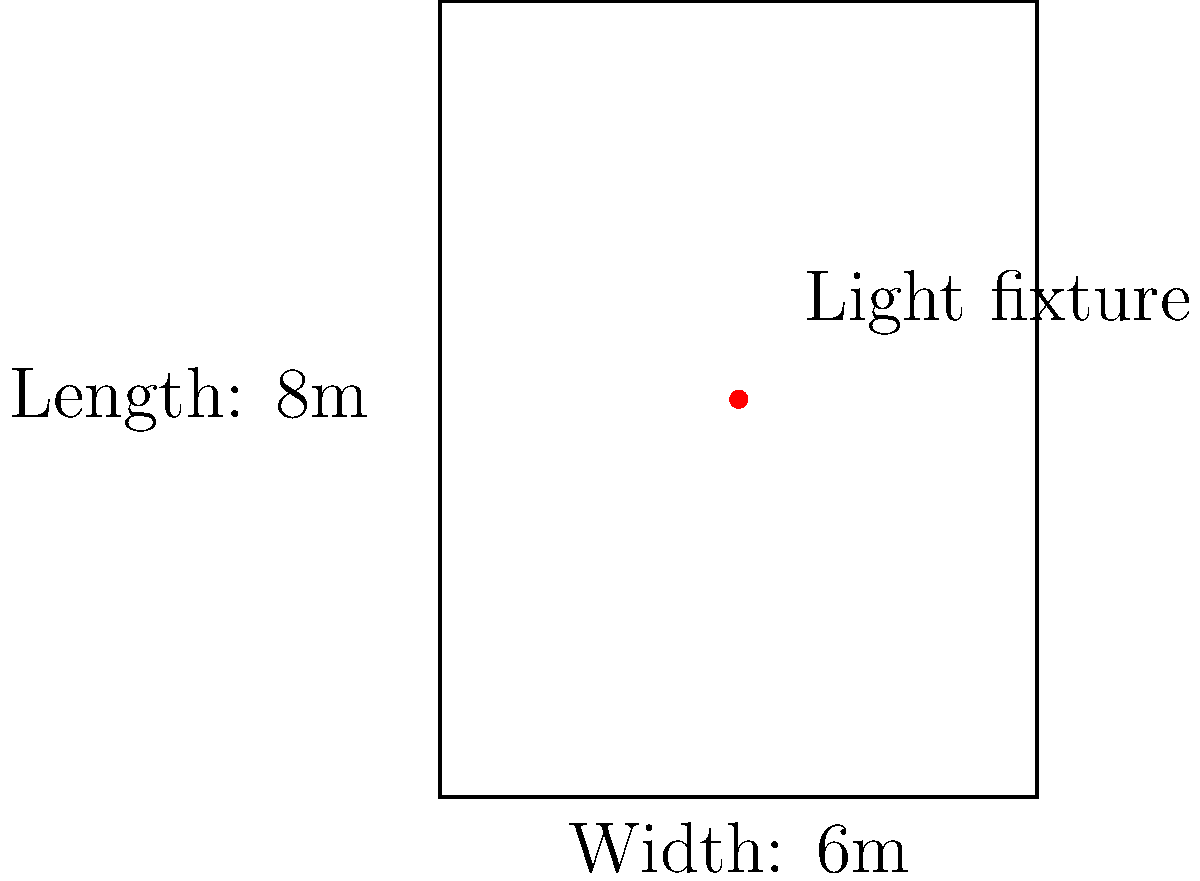As an eco-conscious interior decorator, you're designing an energy-efficient lighting layout for a rectangular room measuring 6m by 8m. You want to place a single light fixture that minimizes the sum of the squared distances from the light to all four corners of the room. Using calculus, determine the optimal position (x, y) for the light fixture. Round your answer to two decimal places. Let's approach this step-by-step:

1) First, we need to set up our function. The sum of the squared distances from the light (x, y) to the four corners (0, 0), (6, 0), (6, 8), and (0, 8) is:

   $$f(x,y) = x^2 + y^2 + (6-x)^2 + y^2 + (6-x)^2 + (8-y)^2 + x^2 + (8-y)^2$$

2) Simplify this expression:

   $$f(x,y) = 2(x^2 + y^2) + 2((6-x)^2 + (8-y)^2)$$
   $$f(x,y) = 2(x^2 + y^2 + 36 - 12x + x^2 + 64 - 16y + y^2)$$
   $$f(x,y) = 2(2x^2 + 2y^2 + 100 - 12x - 16y)$$
   $$f(x,y) = 4x^2 + 4y^2 + 200 - 24x - 32y$$

3) To find the minimum, we need to find where the partial derivatives are zero:

   $$\frac{\partial f}{\partial x} = 8x - 24 = 0$$
   $$\frac{\partial f}{\partial y} = 8y - 32 = 0$$

4) Solve these equations:

   $$8x = 24 \implies x = 3$$
   $$8y = 32 \implies y = 4$$

5) To confirm this is a minimum, we can check the second derivatives:

   $$\frac{\partial^2 f}{\partial x^2} = 8 > 0$$
   $$\frac{\partial^2 f}{\partial y^2} = 8 > 0$$

   Since both are positive, this confirms a minimum.

6) Therefore, the optimal position for the light fixture is (3, 4).
Answer: (3.00, 4.00) 